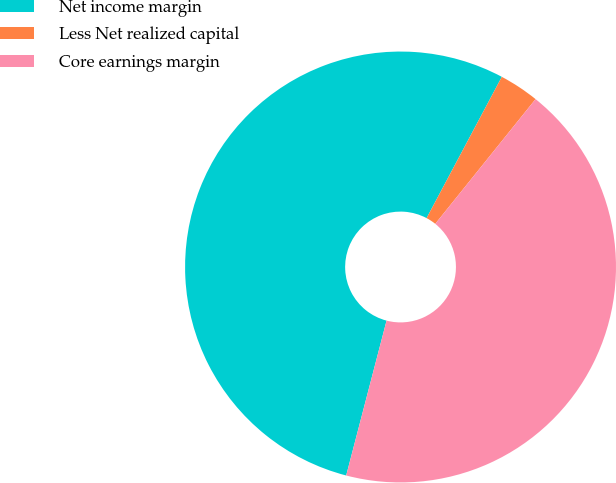Convert chart. <chart><loc_0><loc_0><loc_500><loc_500><pie_chart><fcel>Net income margin<fcel>Less Net realized capital<fcel>Core earnings margin<nl><fcel>53.73%<fcel>2.99%<fcel>43.28%<nl></chart> 